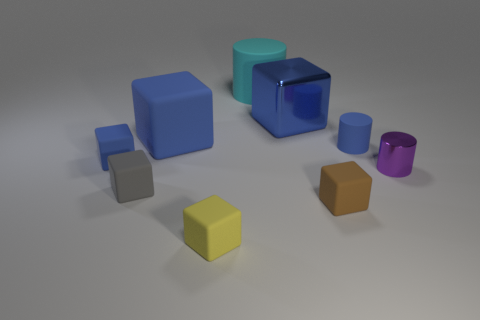Is there a large rubber thing that has the same color as the large matte cube?
Provide a succinct answer. No. There is a purple thing that is the same size as the gray thing; what shape is it?
Your response must be concise. Cylinder. What number of gray things are behind the matte thing that is left of the gray object?
Provide a succinct answer. 0. Do the tiny rubber cylinder and the large rubber cylinder have the same color?
Your answer should be very brief. No. How many other things are there of the same material as the tiny purple object?
Your answer should be very brief. 1. What shape is the large blue object that is on the left side of the big object behind the large blue shiny cube?
Keep it short and to the point. Cube. What size is the metallic object that is on the left side of the purple object?
Make the answer very short. Large. Is the blue cylinder made of the same material as the gray cube?
Provide a succinct answer. Yes. The big cyan object that is made of the same material as the brown block is what shape?
Provide a succinct answer. Cylinder. Is there any other thing that has the same color as the shiny cube?
Your answer should be very brief. Yes. 